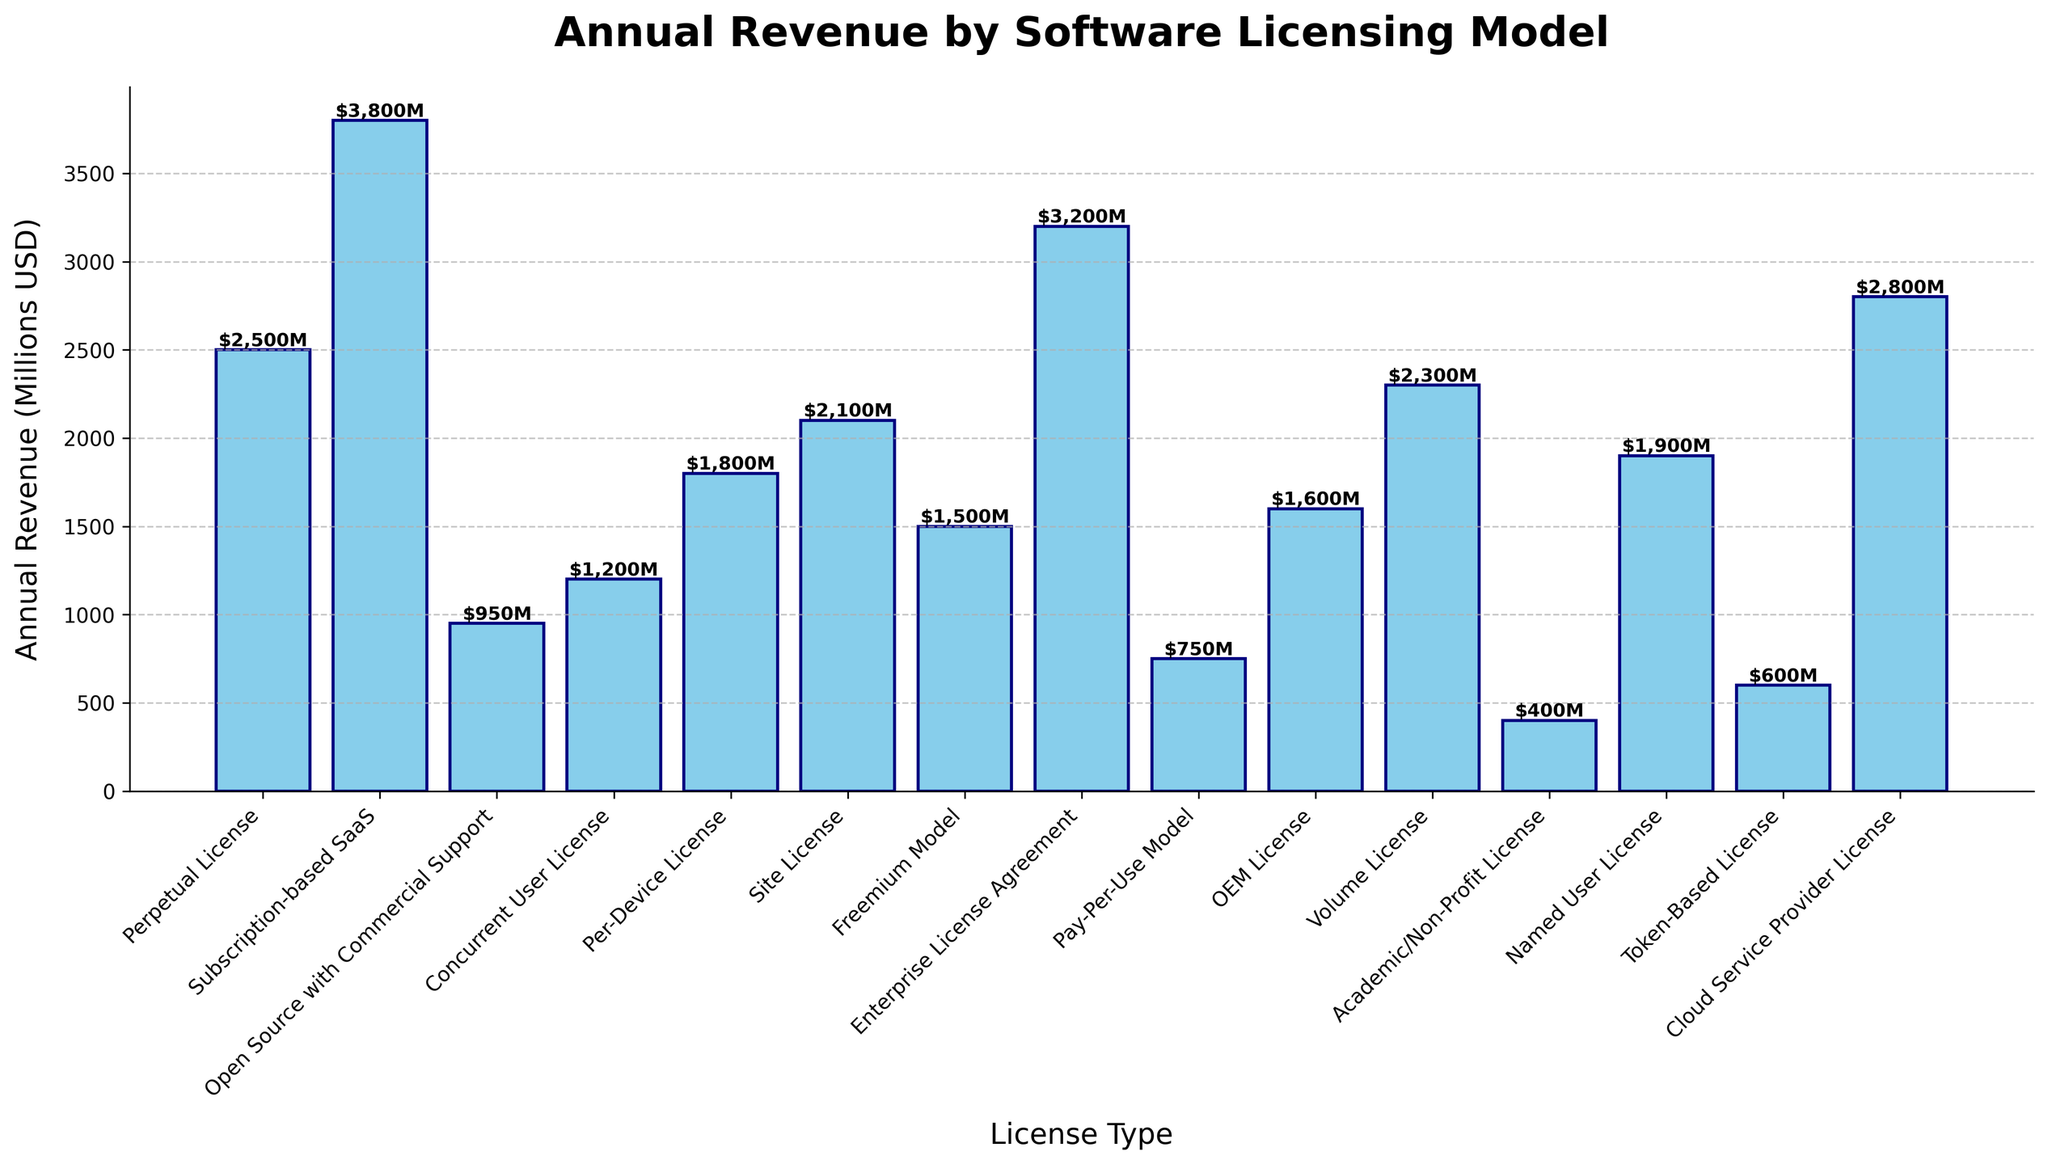Which licensing model generates the highest annual revenue? Identify the highest bar and read its label, "Subscription-based SaaS", which indicates it generates the highest revenue.
Answer: Subscription-based SaaS Which licensing model generates the lowest annual revenue? Identify the shortest bar and read its label, "Academic/Non-Profit License", which indicates it generates the lowest revenue.
Answer: Academic/Non-Profit License What is the total annual revenue generated by all licensing models combined? Add the values of all the bars: 2500 + 3800 + 950 + 1200 + 1800 + 2100 + 1500 + 3200 + 750 + 1600 + 2300 + 400 + 1900 + 600 + 2800 = 30000 million USD.
Answer: 30000 million USD How much more revenue does the "Subscription-based SaaS" model generate compared to the "Perpetual License" model? Subtract the revenue of the "Perpetual License" from "Subscription-based SaaS": 3800 - 2500 = 1300 million USD.
Answer: 1300 million USD Which two licensing models have the closest annual revenues, and what is the difference between them? Compare all the revenue values and find the smallest difference. The closest revenues are the "OEM License" (1600) and "Freemium Model" (1500) with a difference of 100 million USD.
Answer: OEM License and Freemium Model, 100 million USD What is the range of annual revenues generated from all licensing models? Find the difference between the highest and lowest revenue values: 3800 million USD (highest) - 400 million USD (lowest) = 3400 million USD.
Answer: 3400 million USD What is the average annual revenue across all licensing models? Calculate the average by dividing the total revenue (30000 million USD) by the number of models (15): 30000 / 15 = 2000 million USD.
Answer: 2000 million USD Rank the top three licensing models by annual revenue. Identify the three highest bars and their labels: 1) "Subscription-based SaaS" (3800), 2) "Enterprise License Agreement" (3200), 3) "Cloud Service Provider License" (2800).
Answer: Subscription-based SaaS, Enterprise License Agreement, Cloud Service Provider License What is the combined revenue of "Site License" and "Enterprise License Agreement"? Add the revenue of both models: 2100 ("Site License") + 3200 ("Enterprise License Agreement") = 5300 million USD.
Answer: 5300 million USD What percentage of the total annual revenue is generated by the "Named User License" model? Divide the revenue of "Named User License" (1900) by total revenue (30000) and multiply by 100: (1900 / 30000) * 100 ≈ 6.33%.
Answer: ≈ 6.33% 